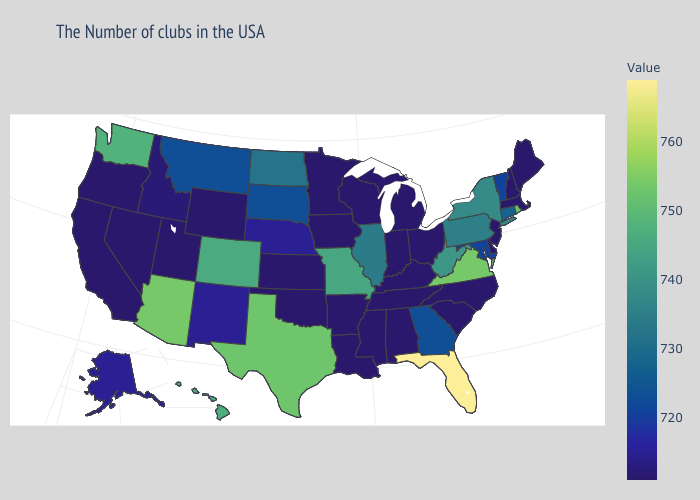Which states hav the highest value in the Northeast?
Quick response, please. Rhode Island. Among the states that border Louisiana , which have the lowest value?
Concise answer only. Mississippi, Arkansas. Does Delaware have a lower value than Missouri?
Give a very brief answer. Yes. 